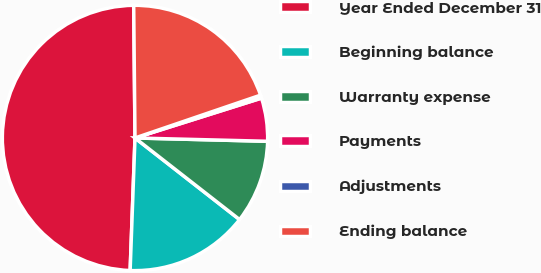Convert chart to OTSL. <chart><loc_0><loc_0><loc_500><loc_500><pie_chart><fcel>Year Ended December 31<fcel>Beginning balance<fcel>Warranty expense<fcel>Payments<fcel>Adjustments<fcel>Ending balance<nl><fcel>49.27%<fcel>15.04%<fcel>10.15%<fcel>5.26%<fcel>0.37%<fcel>19.93%<nl></chart> 